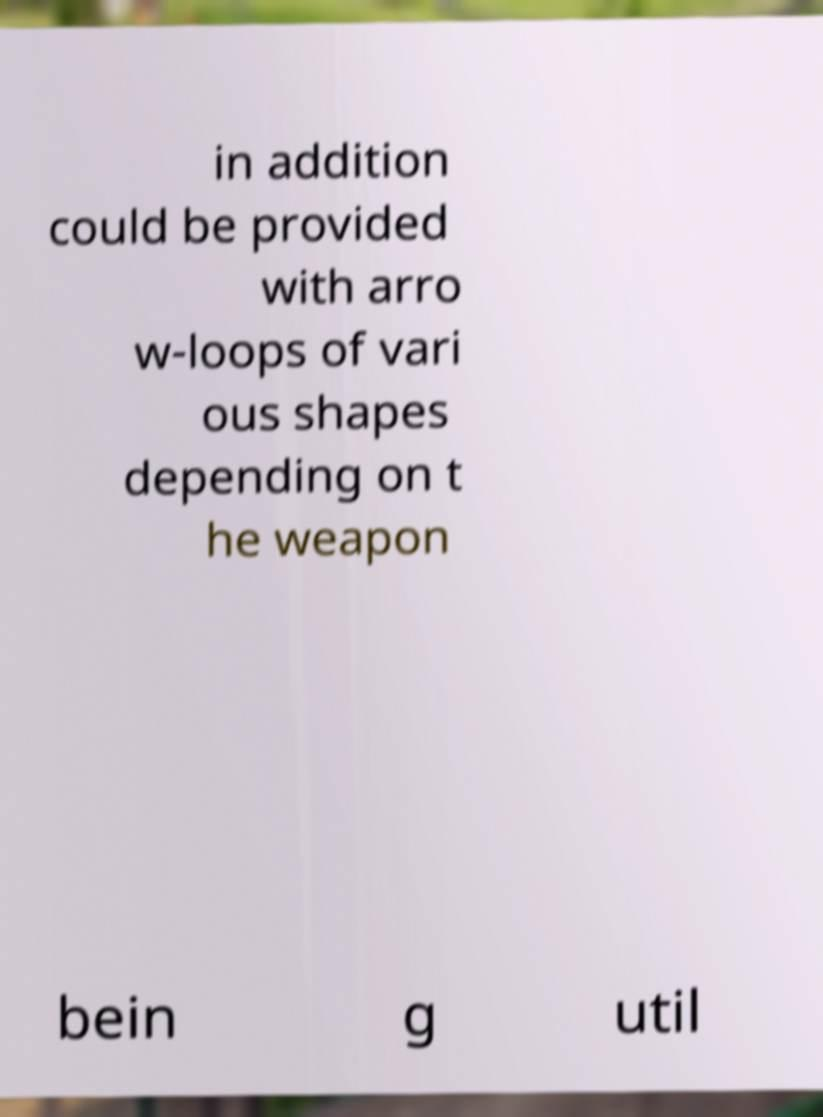Could you extract and type out the text from this image? in addition could be provided with arro w-loops of vari ous shapes depending on t he weapon bein g util 